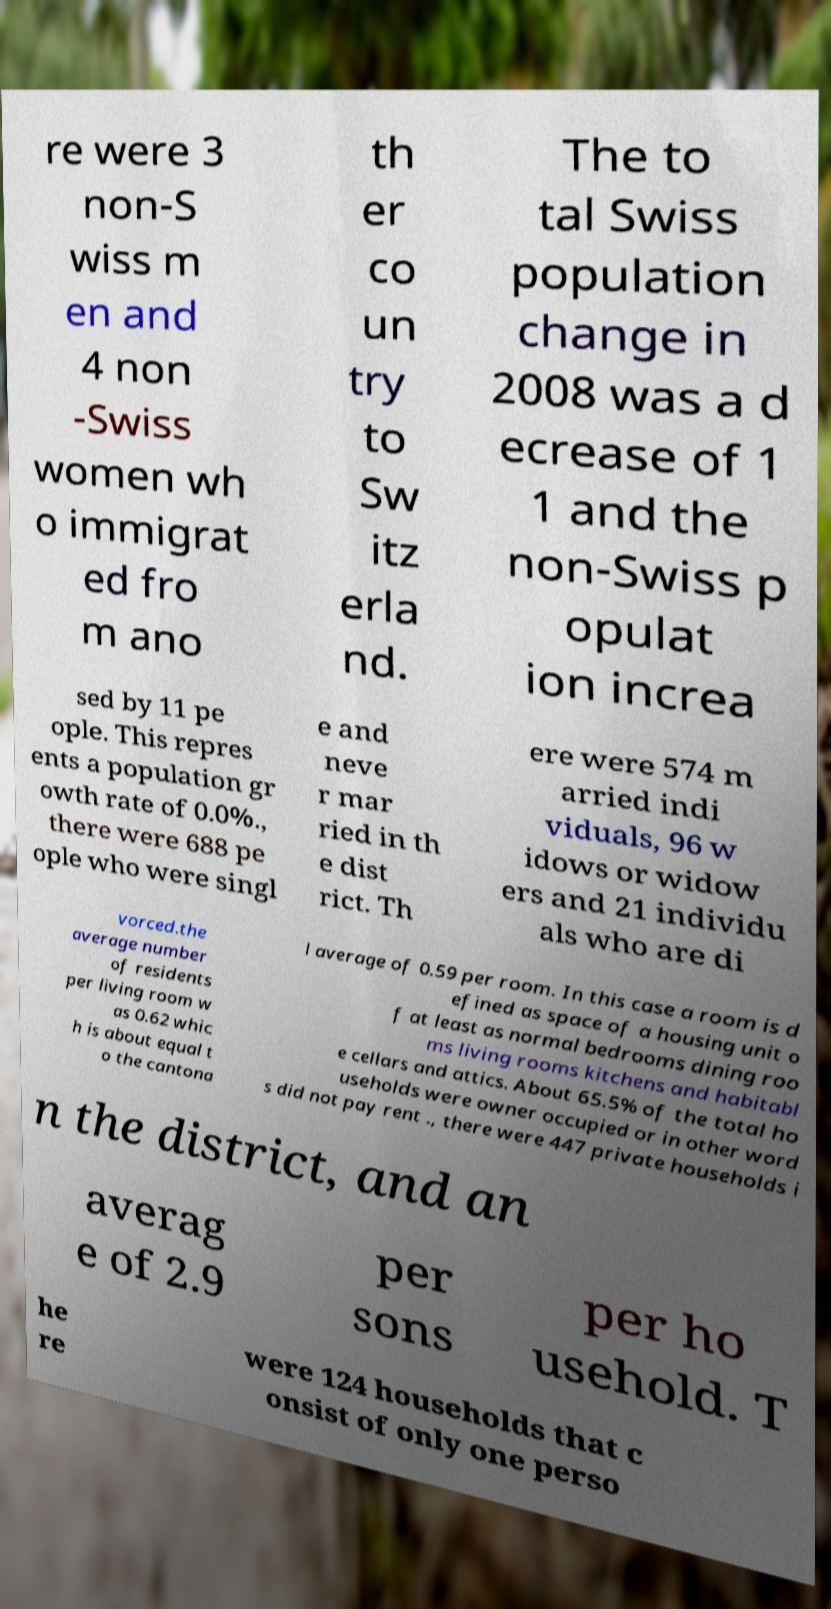I need the written content from this picture converted into text. Can you do that? re were 3 non-S wiss m en and 4 non -Swiss women wh o immigrat ed fro m ano th er co un try to Sw itz erla nd. The to tal Swiss population change in 2008 was a d ecrease of 1 1 and the non-Swiss p opulat ion increa sed by 11 pe ople. This repres ents a population gr owth rate of 0.0%., there were 688 pe ople who were singl e and neve r mar ried in th e dist rict. Th ere were 574 m arried indi viduals, 96 w idows or widow ers and 21 individu als who are di vorced.the average number of residents per living room w as 0.62 whic h is about equal t o the cantona l average of 0.59 per room. In this case a room is d efined as space of a housing unit o f at least as normal bedrooms dining roo ms living rooms kitchens and habitabl e cellars and attics. About 65.5% of the total ho useholds were owner occupied or in other word s did not pay rent ., there were 447 private households i n the district, and an averag e of 2.9 per sons per ho usehold. T he re were 124 households that c onsist of only one perso 